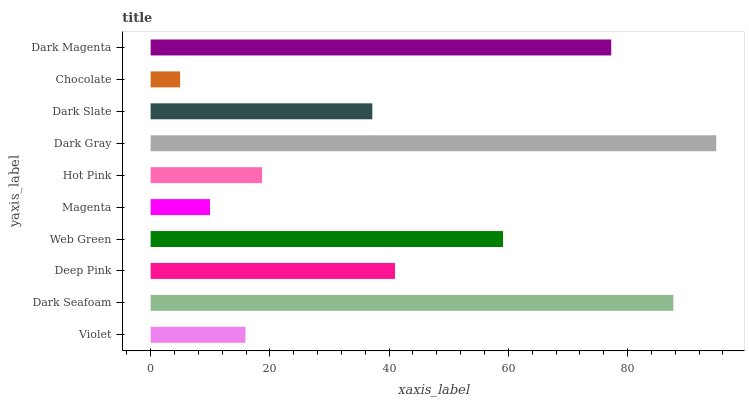Is Chocolate the minimum?
Answer yes or no. Yes. Is Dark Gray the maximum?
Answer yes or no. Yes. Is Dark Seafoam the minimum?
Answer yes or no. No. Is Dark Seafoam the maximum?
Answer yes or no. No. Is Dark Seafoam greater than Violet?
Answer yes or no. Yes. Is Violet less than Dark Seafoam?
Answer yes or no. Yes. Is Violet greater than Dark Seafoam?
Answer yes or no. No. Is Dark Seafoam less than Violet?
Answer yes or no. No. Is Deep Pink the high median?
Answer yes or no. Yes. Is Dark Slate the low median?
Answer yes or no. Yes. Is Dark Seafoam the high median?
Answer yes or no. No. Is Dark Magenta the low median?
Answer yes or no. No. 